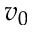Convert formula to latex. <formula><loc_0><loc_0><loc_500><loc_500>v _ { 0 }</formula> 